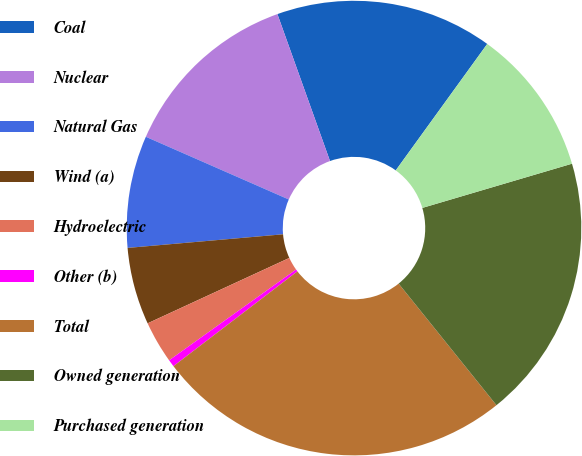<chart> <loc_0><loc_0><loc_500><loc_500><pie_chart><fcel>Coal<fcel>Nuclear<fcel>Natural Gas<fcel>Wind (a)<fcel>Hydroelectric<fcel>Other (b)<fcel>Total<fcel>Owned generation<fcel>Purchased generation<nl><fcel>15.44%<fcel>12.95%<fcel>7.97%<fcel>5.49%<fcel>3.0%<fcel>0.51%<fcel>25.39%<fcel>18.79%<fcel>10.46%<nl></chart> 